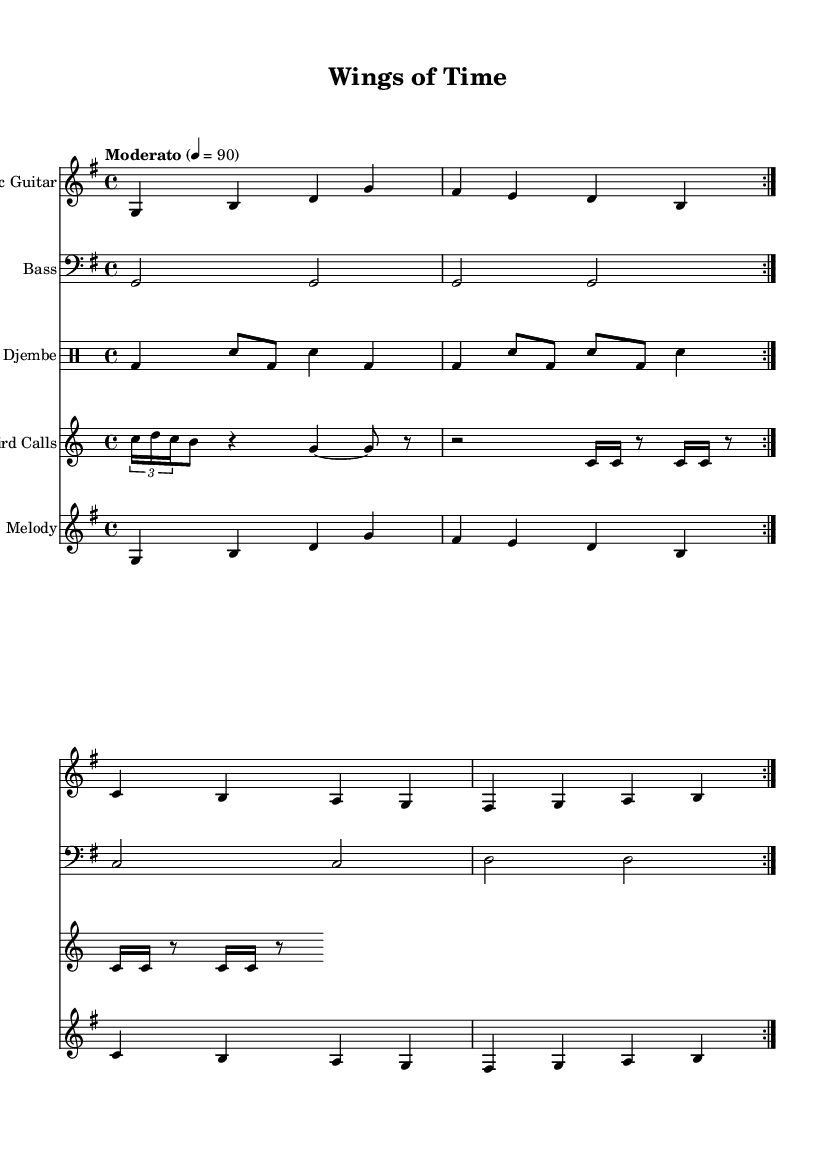What is the key signature of this music? The key signature is G major, which has one sharp (F#).
Answer: G major What is the time signature of this piece? The time signature is indicated as 4/4, meaning there are four beats per measure, and the quarter note gets one beat.
Answer: 4/4 What is the tempo marking? The tempo marking is "Moderato," which indicates a moderate pace, typically around 86-108 beats per minute.
Answer: Moderato Which instrument plays the bird calls? The bird calls are played by the staff labeled "Bird Calls," which includes the robin call, mourning dove, and woodpecker.
Answer: Bird Calls What are the genres represented in this piece? The piece is categorized as acoustic rock, combining traditional acoustic elements with rock influences, highlighted by the guitar and djembe instruments.
Answer: Acoustic rock How many measures are in the acoustic guitar part before repeating? The acoustic guitar part has 4 measures before it repeats, as indicated by the "repeat volta 2" marking at the beginning of the section.
Answer: 4 measures What type of sound does the woodpecker staff represent? The woodpecker staff indicates percussion-like sounds represented by drum notation, simulating the tapping of a woodpecker.
Answer: Percussion sounds 